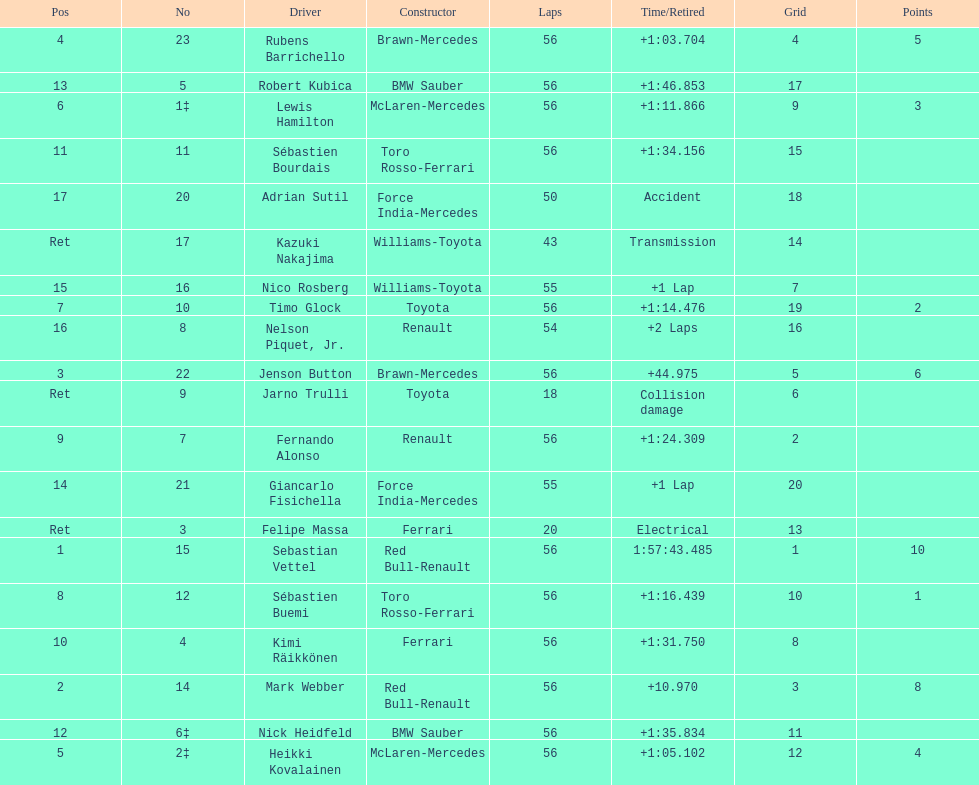Write the full table. {'header': ['Pos', 'No', 'Driver', 'Constructor', 'Laps', 'Time/Retired', 'Grid', 'Points'], 'rows': [['4', '23', 'Rubens Barrichello', 'Brawn-Mercedes', '56', '+1:03.704', '4', '5'], ['13', '5', 'Robert Kubica', 'BMW Sauber', '56', '+1:46.853', '17', ''], ['6', '1‡', 'Lewis Hamilton', 'McLaren-Mercedes', '56', '+1:11.866', '9', '3'], ['11', '11', 'Sébastien Bourdais', 'Toro Rosso-Ferrari', '56', '+1:34.156', '15', ''], ['17', '20', 'Adrian Sutil', 'Force India-Mercedes', '50', 'Accident', '18', ''], ['Ret', '17', 'Kazuki Nakajima', 'Williams-Toyota', '43', 'Transmission', '14', ''], ['15', '16', 'Nico Rosberg', 'Williams-Toyota', '55', '+1 Lap', '7', ''], ['7', '10', 'Timo Glock', 'Toyota', '56', '+1:14.476', '19', '2'], ['16', '8', 'Nelson Piquet, Jr.', 'Renault', '54', '+2 Laps', '16', ''], ['3', '22', 'Jenson Button', 'Brawn-Mercedes', '56', '+44.975', '5', '6'], ['Ret', '9', 'Jarno Trulli', 'Toyota', '18', 'Collision damage', '6', ''], ['9', '7', 'Fernando Alonso', 'Renault', '56', '+1:24.309', '2', ''], ['14', '21', 'Giancarlo Fisichella', 'Force India-Mercedes', '55', '+1 Lap', '20', ''], ['Ret', '3', 'Felipe Massa', 'Ferrari', '20', 'Electrical', '13', ''], ['1', '15', 'Sebastian Vettel', 'Red Bull-Renault', '56', '1:57:43.485', '1', '10'], ['8', '12', 'Sébastien Buemi', 'Toro Rosso-Ferrari', '56', '+1:16.439', '10', '1'], ['10', '4', 'Kimi Räikkönen', 'Ferrari', '56', '+1:31.750', '8', ''], ['2', '14', 'Mark Webber', 'Red Bull-Renault', '56', '+10.970', '3', '8'], ['12', '6‡', 'Nick Heidfeld', 'BMW Sauber', '56', '+1:35.834', '11', ''], ['5', '2‡', 'Heikki Kovalainen', 'McLaren-Mercedes', '56', '+1:05.102', '12', '4']]} How many drivers did not finish 56 laps? 7. 